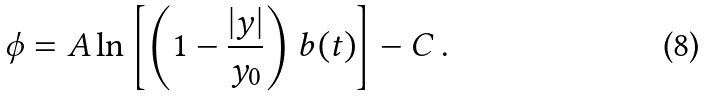Convert formula to latex. <formula><loc_0><loc_0><loc_500><loc_500>\phi = A \ln \left [ \left ( 1 - \frac { | y | } { y _ { 0 } } \right ) b ( t ) \right ] - C \, .</formula> 